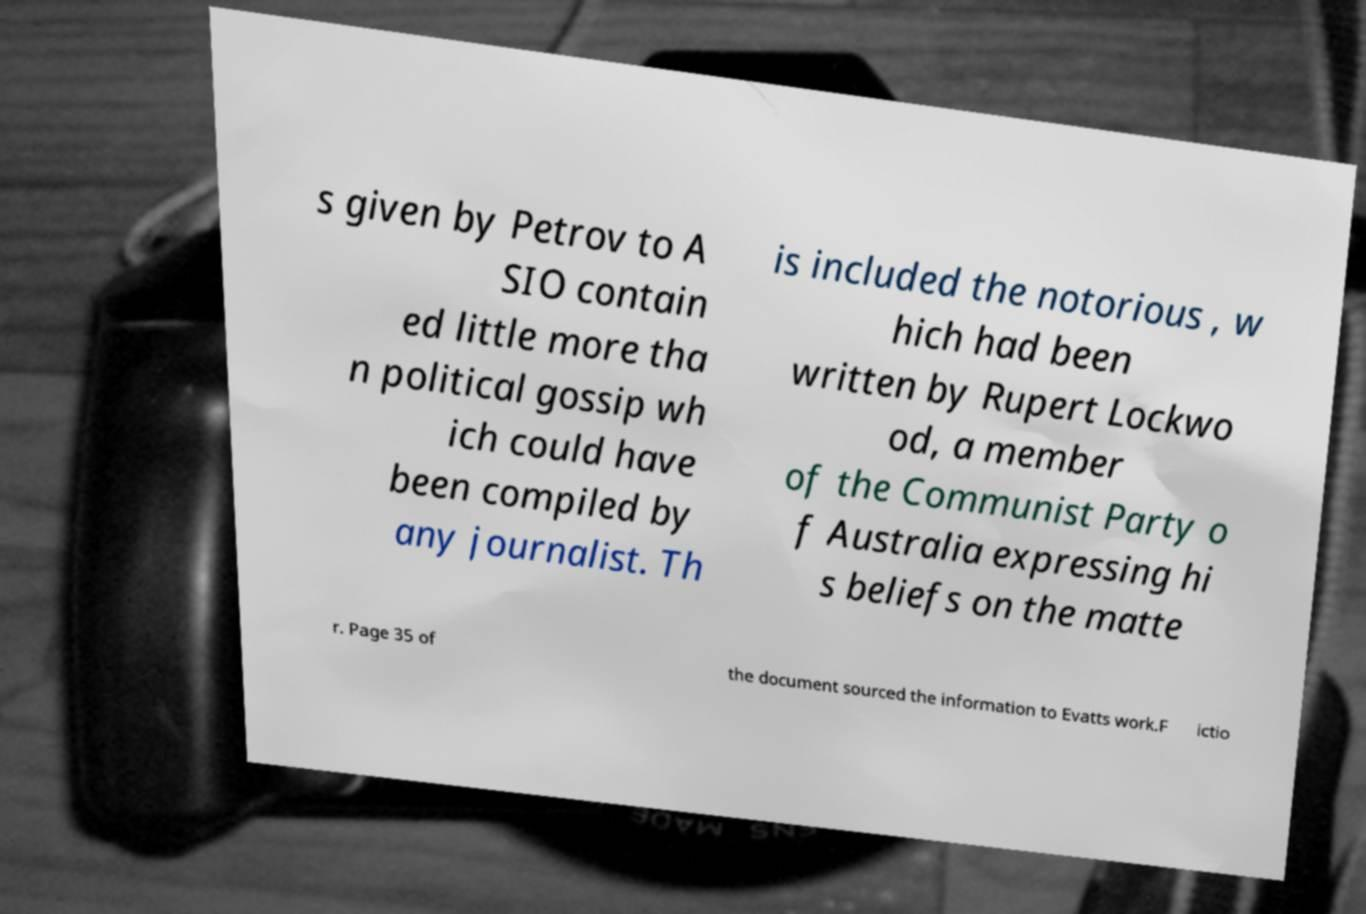I need the written content from this picture converted into text. Can you do that? s given by Petrov to A SIO contain ed little more tha n political gossip wh ich could have been compiled by any journalist. Th is included the notorious , w hich had been written by Rupert Lockwo od, a member of the Communist Party o f Australia expressing hi s beliefs on the matte r. Page 35 of the document sourced the information to Evatts work.F ictio 